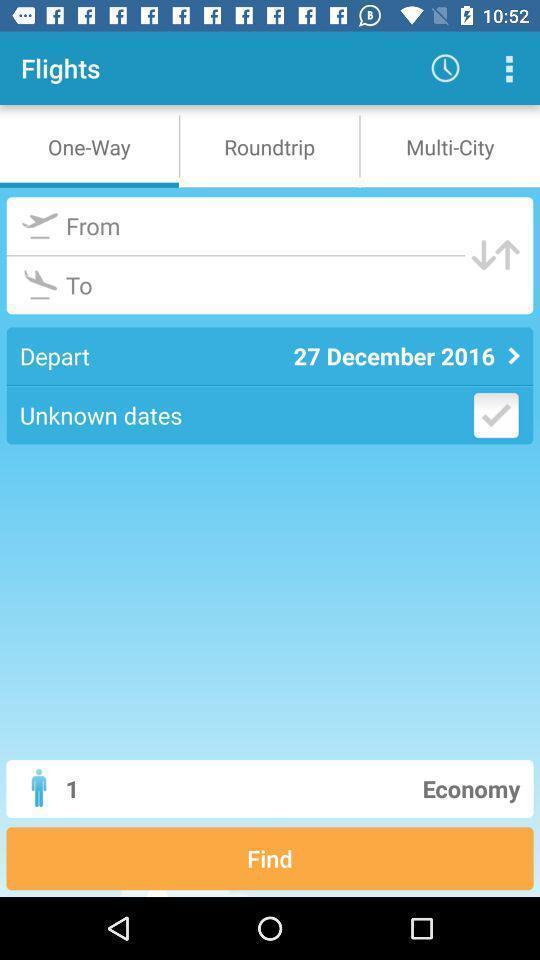Explain what's happening in this screen capture. Page showing various options in a flight booking app. 